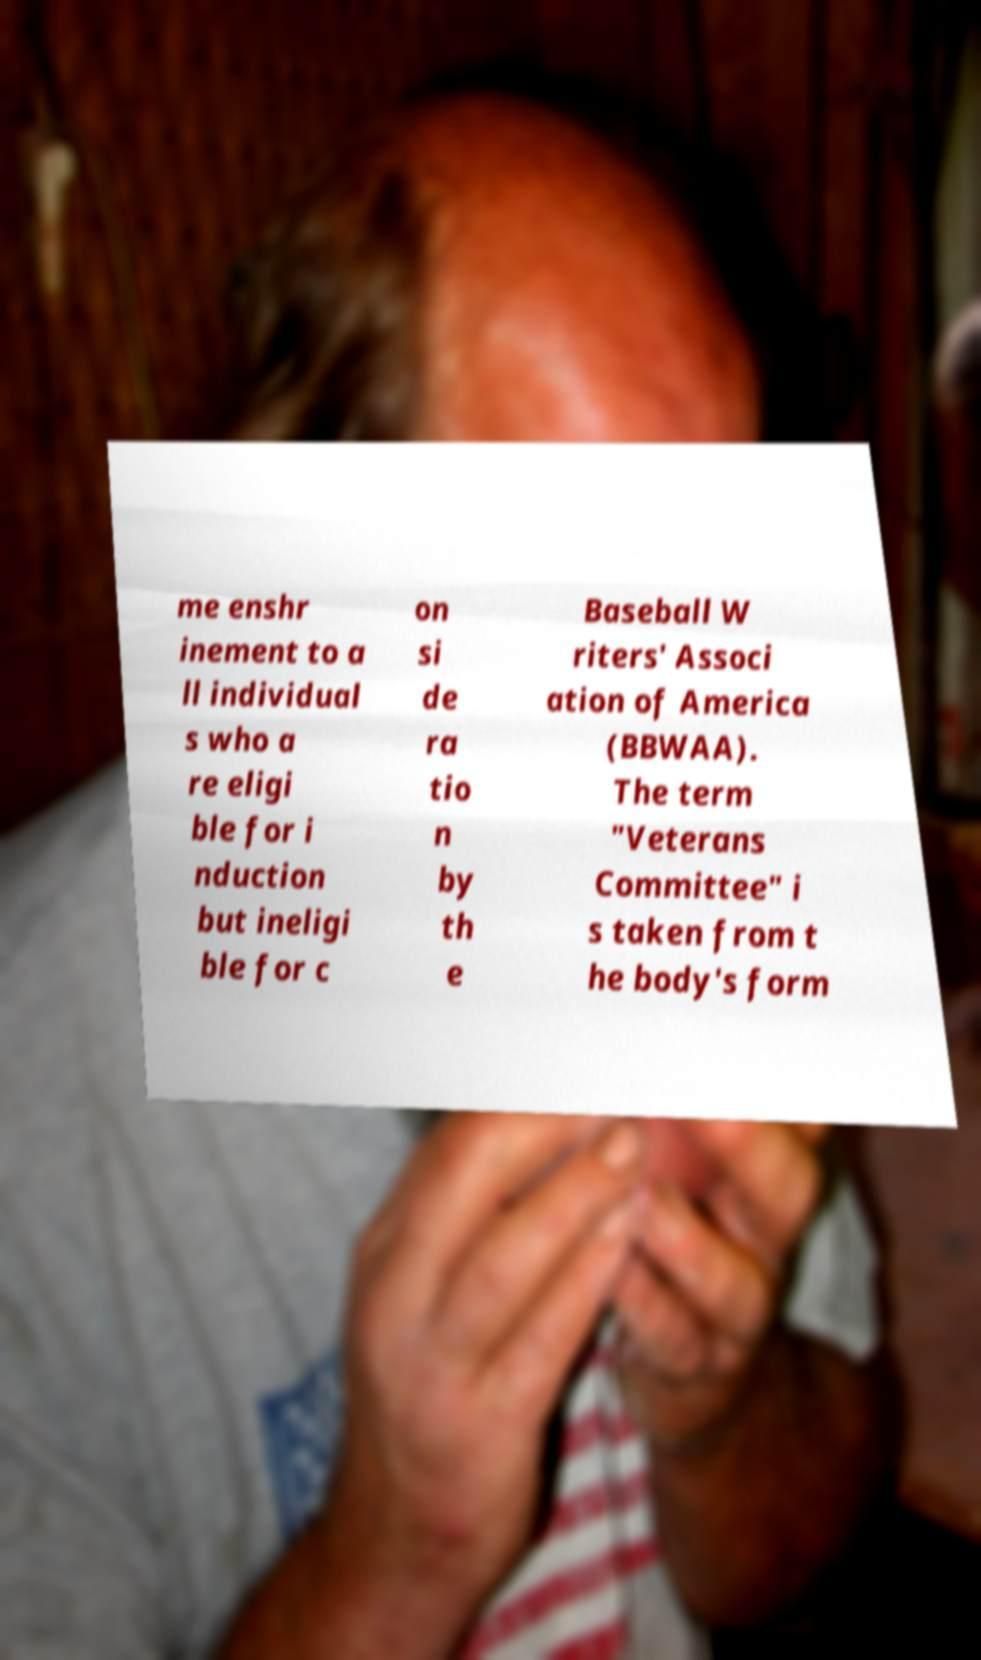Can you read and provide the text displayed in the image?This photo seems to have some interesting text. Can you extract and type it out for me? me enshr inement to a ll individual s who a re eligi ble for i nduction but ineligi ble for c on si de ra tio n by th e Baseball W riters' Associ ation of America (BBWAA). The term "Veterans Committee" i s taken from t he body's form 